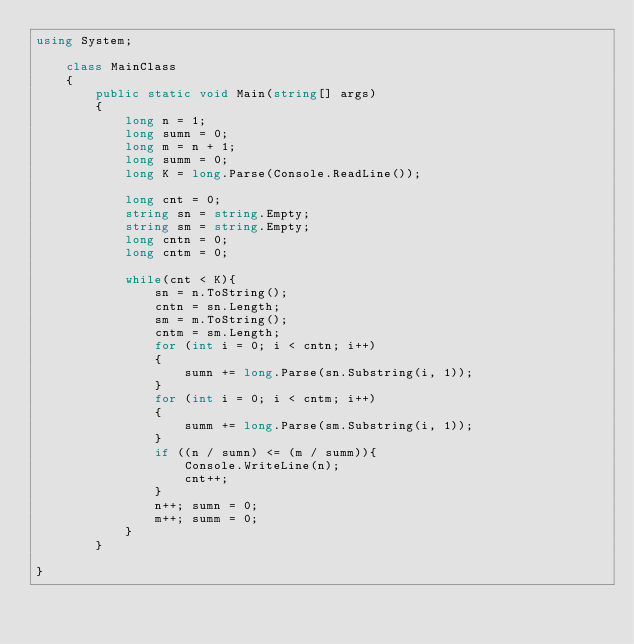Convert code to text. <code><loc_0><loc_0><loc_500><loc_500><_C#_>using System;

	class MainClass
	{
		public static void Main(string[] args)
		{
			long n = 1;
			long sumn = 0;
			long m = n + 1;
			long summ = 0;
			long K = long.Parse(Console.ReadLine());
			
			long cnt = 0;
			string sn = string.Empty;
			string sm = string.Empty;
			long cntn = 0;
			long cntm = 0;

			while(cnt < K){
				sn = n.ToString();
				cntn = sn.Length;
				sm = m.ToString();
				cntm = sm.Length;
				for (int i = 0; i < cntn; i++)
				{
					sumn += long.Parse(sn.Substring(i, 1));
				}
				for (int i = 0; i < cntm; i++)
				{
					summ += long.Parse(sm.Substring(i, 1));
				}
				if ((n / sumn) <= (m / summ)){
					Console.WriteLine(n);
					cnt++;
				}
				n++; sumn = 0;
				m++; summ = 0;
			}
		}
	
}
</code> 